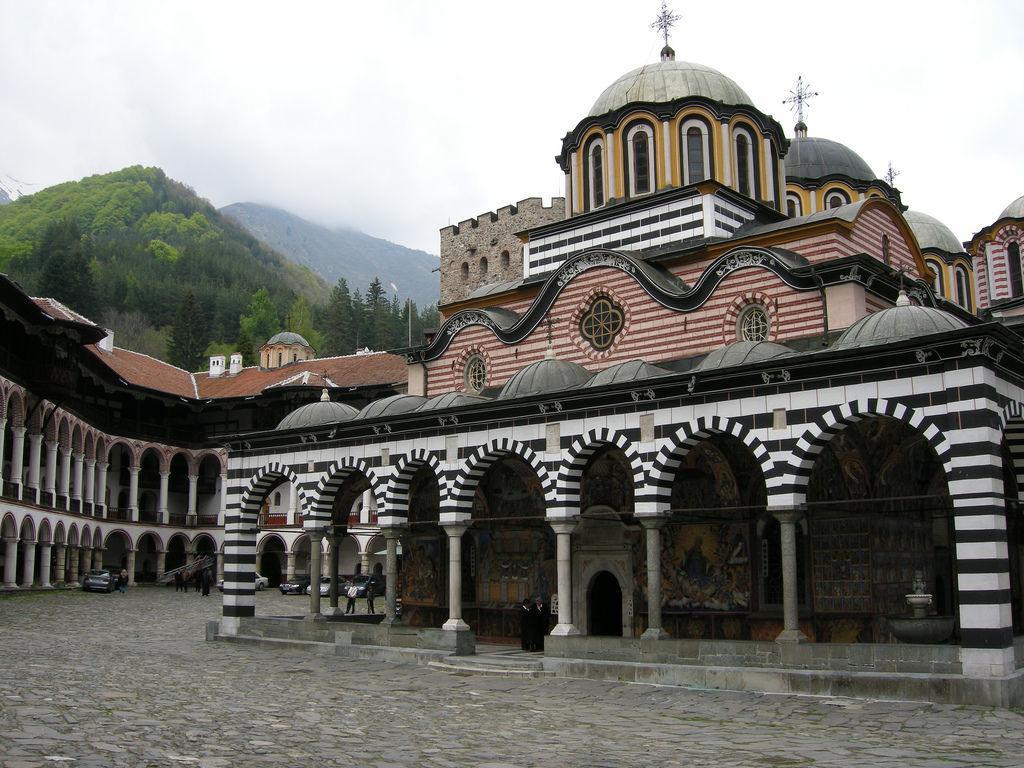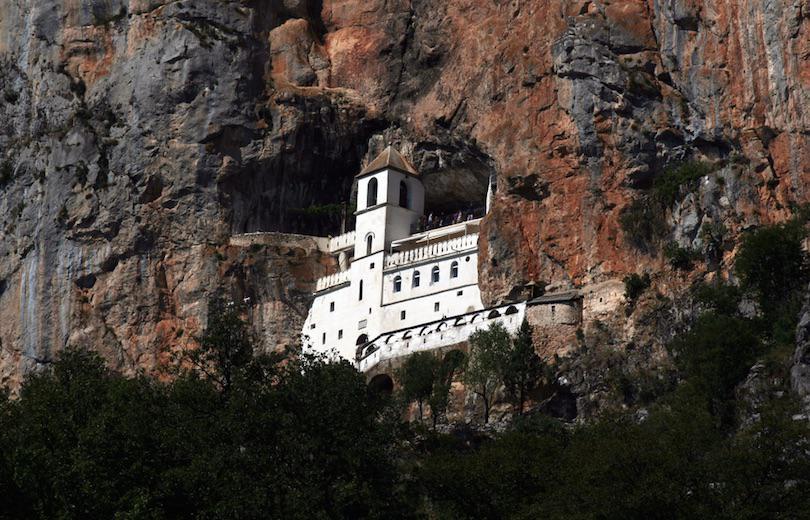The first image is the image on the left, the second image is the image on the right. Assess this claim about the two images: "In at least one image there is a squared white walled building with at least three floors.". Correct or not? Answer yes or no. Yes. 